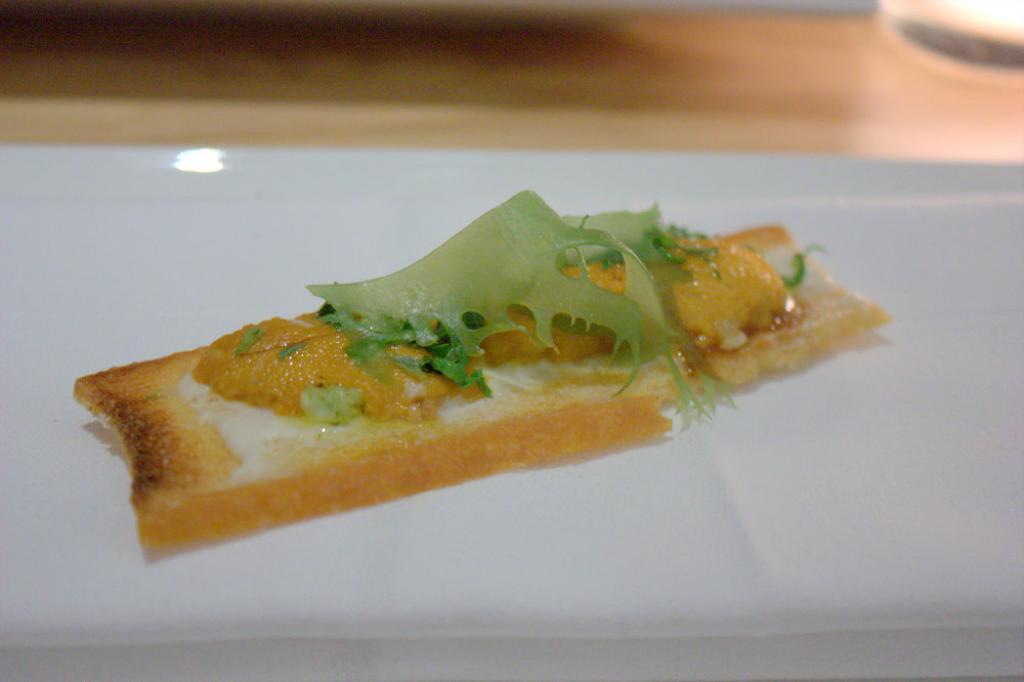What is the color of the main object in the image? The main object in the image is white. What is placed on the white object? Food is present on the white object. Can you describe the colors of the food? The food has green, brown, and white colors. How many boys are playing the guitar in the image? There are no boys or guitars present in the image. 